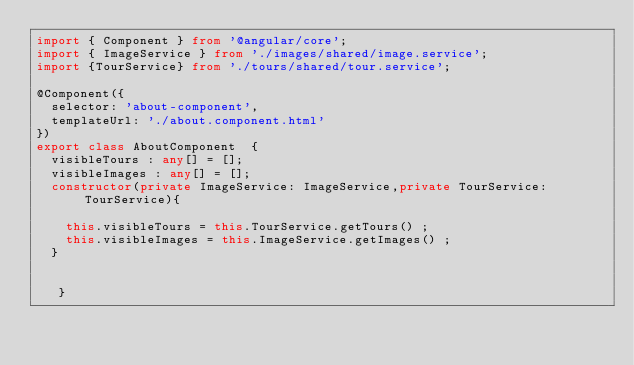<code> <loc_0><loc_0><loc_500><loc_500><_TypeScript_>import { Component } from '@angular/core';
import { ImageService } from './images/shared/image.service';
import {TourService} from './tours/shared/tour.service';

@Component({
  selector: 'about-component',
  templateUrl: './about.component.html'
})
export class AboutComponent  { 
  visibleTours : any[] = [];
  visibleImages : any[] = [];
  constructor(private ImageService: ImageService,private TourService: TourService){
    
    this.visibleTours = this.TourService.getTours() ;
    this.visibleImages = this.ImageService.getImages() ;
  }

  
   }
</code> 